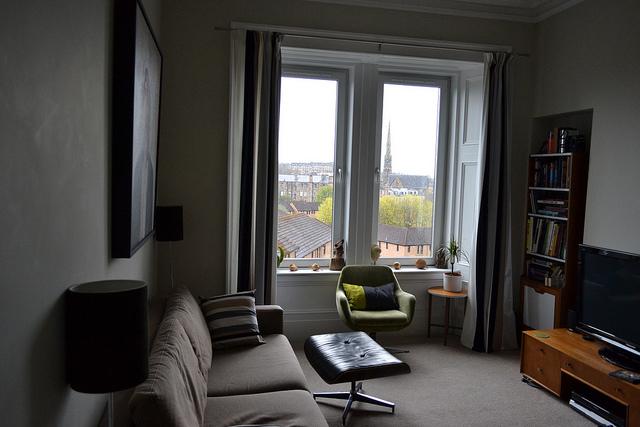What tall item can be seen through the window in the background?
Short answer required. Steeple. What is on the small table to the right and below the windows?
Keep it brief. Plant. Is the TV turned on?
Concise answer only. No. 